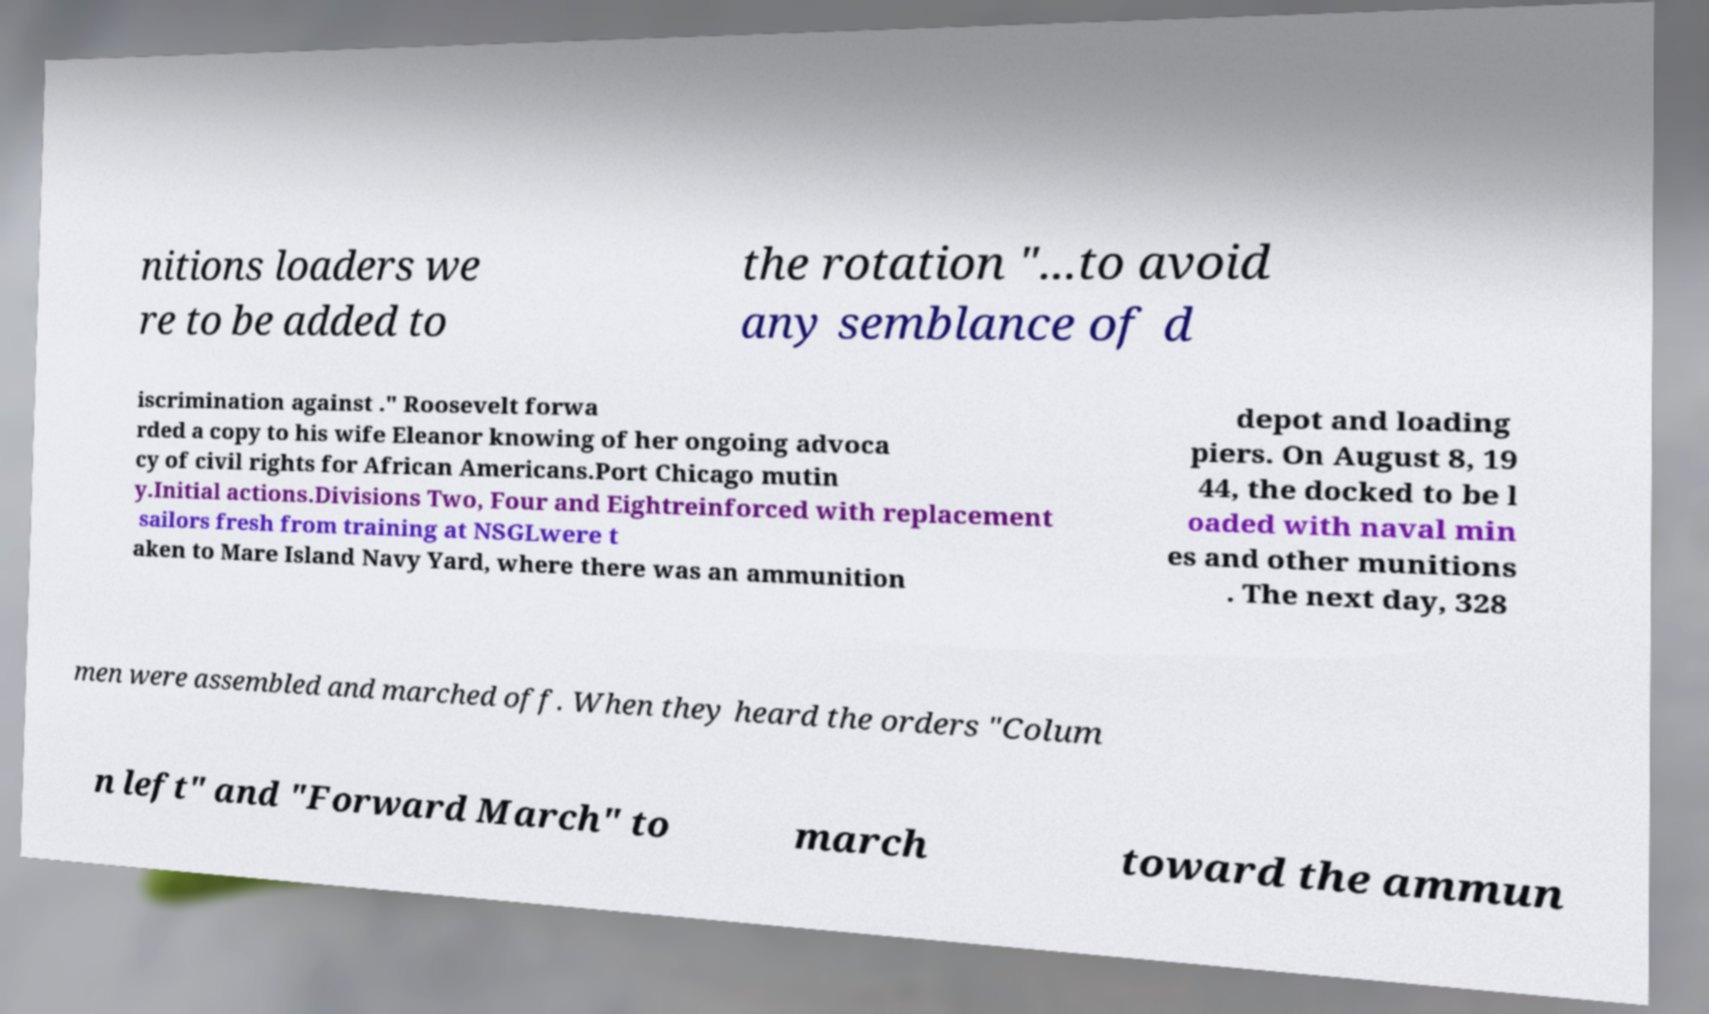Please identify and transcribe the text found in this image. nitions loaders we re to be added to the rotation "...to avoid any semblance of d iscrimination against ." Roosevelt forwa rded a copy to his wife Eleanor knowing of her ongoing advoca cy of civil rights for African Americans.Port Chicago mutin y.Initial actions.Divisions Two, Four and Eightreinforced with replacement sailors fresh from training at NSGLwere t aken to Mare Island Navy Yard, where there was an ammunition depot and loading piers. On August 8, 19 44, the docked to be l oaded with naval min es and other munitions . The next day, 328 men were assembled and marched off. When they heard the orders "Colum n left" and "Forward March" to march toward the ammun 